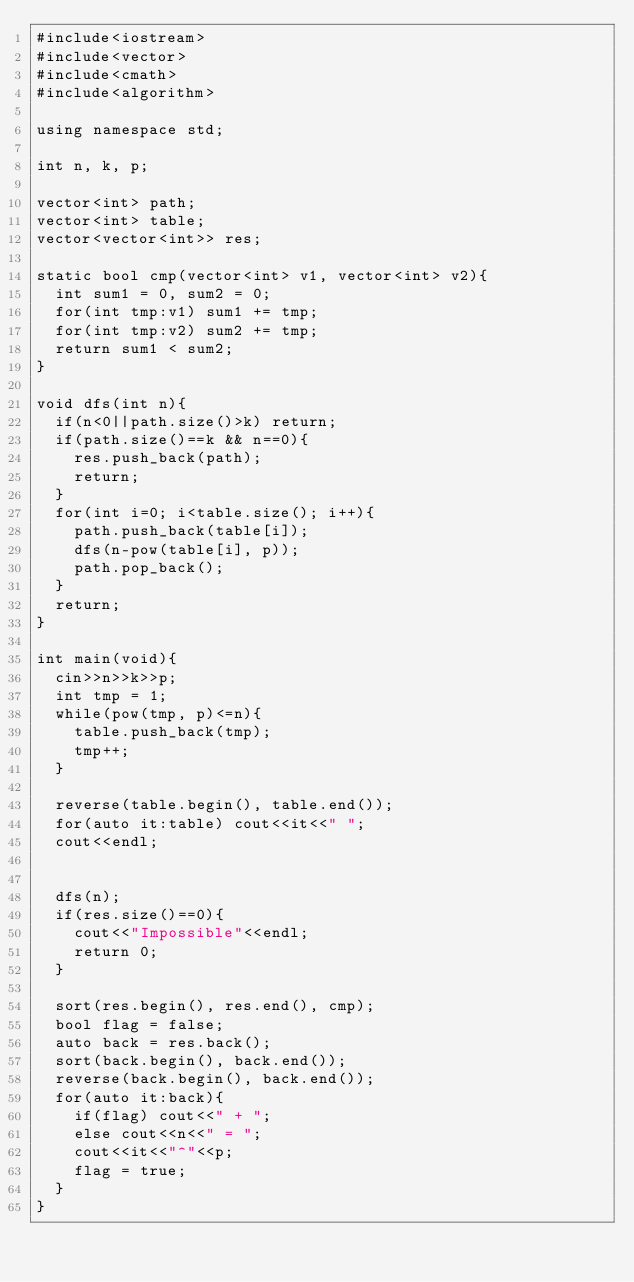<code> <loc_0><loc_0><loc_500><loc_500><_C++_>#include<iostream>
#include<vector>
#include<cmath>
#include<algorithm>

using namespace std;

int n, k, p;

vector<int> path;
vector<int> table;
vector<vector<int>> res;

static bool cmp(vector<int> v1, vector<int> v2){
	int sum1 = 0, sum2 = 0;
	for(int tmp:v1) sum1 += tmp;
	for(int tmp:v2) sum2 += tmp;
	return sum1 < sum2;
}

void dfs(int n){
	if(n<0||path.size()>k) return;
	if(path.size()==k && n==0){
		res.push_back(path);
		return;
	}
	for(int i=0; i<table.size(); i++){
		path.push_back(table[i]);
		dfs(n-pow(table[i], p));
		path.pop_back();
	}
	return;
}

int main(void){
	cin>>n>>k>>p;
	int tmp = 1;
	while(pow(tmp, p)<=n){
		table.push_back(tmp);
		tmp++;
	}

	reverse(table.begin(), table.end());
	for(auto it:table) cout<<it<<" ";
	cout<<endl;


	dfs(n);
	if(res.size()==0){
		cout<<"Impossible"<<endl;
		return 0;
	}

	sort(res.begin(), res.end(), cmp);
	bool flag = false;
	auto back = res.back();
	sort(back.begin(), back.end());
	reverse(back.begin(), back.end());
	for(auto it:back){
		if(flag) cout<<" + ";
		else cout<<n<<" = ";
		cout<<it<<"^"<<p;
		flag = true;
	}
}
</code> 